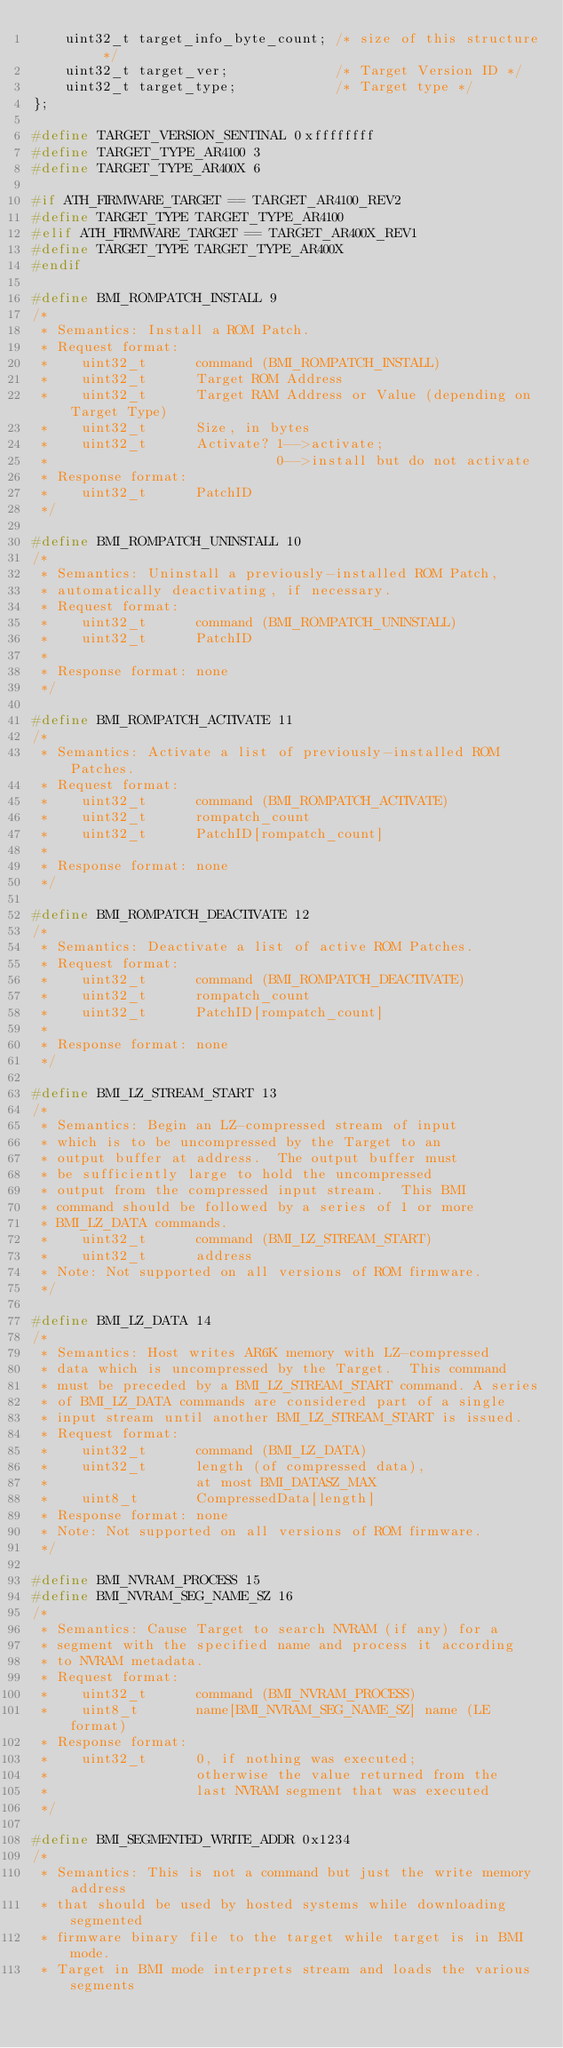<code> <loc_0><loc_0><loc_500><loc_500><_C_>    uint32_t target_info_byte_count; /* size of this structure */
    uint32_t target_ver;             /* Target Version ID */
    uint32_t target_type;            /* Target type */
};

#define TARGET_VERSION_SENTINAL 0xffffffff
#define TARGET_TYPE_AR4100 3
#define TARGET_TYPE_AR400X 6

#if ATH_FIRMWARE_TARGET == TARGET_AR4100_REV2
#define TARGET_TYPE TARGET_TYPE_AR4100
#elif ATH_FIRMWARE_TARGET == TARGET_AR400X_REV1
#define TARGET_TYPE TARGET_TYPE_AR400X
#endif

#define BMI_ROMPATCH_INSTALL 9
/*
 * Semantics: Install a ROM Patch.
 * Request format:
 *    uint32_t      command (BMI_ROMPATCH_INSTALL)
 *    uint32_t      Target ROM Address
 *    uint32_t      Target RAM Address or Value (depending on Target Type)
 *    uint32_t      Size, in bytes
 *    uint32_t      Activate? 1-->activate;
 *                            0-->install but do not activate
 * Response format:
 *    uint32_t      PatchID
 */

#define BMI_ROMPATCH_UNINSTALL 10
/*
 * Semantics: Uninstall a previously-installed ROM Patch,
 * automatically deactivating, if necessary.
 * Request format:
 *    uint32_t      command (BMI_ROMPATCH_UNINSTALL)
 *    uint32_t      PatchID
 *
 * Response format: none
 */

#define BMI_ROMPATCH_ACTIVATE 11
/*
 * Semantics: Activate a list of previously-installed ROM Patches.
 * Request format:
 *    uint32_t      command (BMI_ROMPATCH_ACTIVATE)
 *    uint32_t      rompatch_count
 *    uint32_t      PatchID[rompatch_count]
 *
 * Response format: none
 */

#define BMI_ROMPATCH_DEACTIVATE 12
/*
 * Semantics: Deactivate a list of active ROM Patches.
 * Request format:
 *    uint32_t      command (BMI_ROMPATCH_DEACTIVATE)
 *    uint32_t      rompatch_count
 *    uint32_t      PatchID[rompatch_count]
 *
 * Response format: none
 */

#define BMI_LZ_STREAM_START 13
/*
 * Semantics: Begin an LZ-compressed stream of input
 * which is to be uncompressed by the Target to an
 * output buffer at address.  The output buffer must
 * be sufficiently large to hold the uncompressed
 * output from the compressed input stream.  This BMI
 * command should be followed by a series of 1 or more
 * BMI_LZ_DATA commands.
 *    uint32_t      command (BMI_LZ_STREAM_START)
 *    uint32_t      address
 * Note: Not supported on all versions of ROM firmware.
 */

#define BMI_LZ_DATA 14
/*
 * Semantics: Host writes AR6K memory with LZ-compressed
 * data which is uncompressed by the Target.  This command
 * must be preceded by a BMI_LZ_STREAM_START command. A series
 * of BMI_LZ_DATA commands are considered part of a single
 * input stream until another BMI_LZ_STREAM_START is issued.
 * Request format:
 *    uint32_t      command (BMI_LZ_DATA)
 *    uint32_t      length (of compressed data),
 *                  at most BMI_DATASZ_MAX
 *    uint8_t       CompressedData[length]
 * Response format: none
 * Note: Not supported on all versions of ROM firmware.
 */

#define BMI_NVRAM_PROCESS 15
#define BMI_NVRAM_SEG_NAME_SZ 16
/*
 * Semantics: Cause Target to search NVRAM (if any) for a
 * segment with the specified name and process it according
 * to NVRAM metadata.
 * Request format:
 *    uint32_t      command (BMI_NVRAM_PROCESS)
 *    uint8_t       name[BMI_NVRAM_SEG_NAME_SZ] name (LE format)
 * Response format:
 *    uint32_t      0, if nothing was executed;
 *                  otherwise the value returned from the
 *                  last NVRAM segment that was executed
 */

#define BMI_SEGMENTED_WRITE_ADDR 0x1234
/*
 * Semantics: This is not a command but just the write memory address
 * that should be used by hosted systems while downloading segmented
 * firmware binary file to the target while target is in BMI mode.
 * Target in BMI mode interprets stream and loads the various segments</code> 